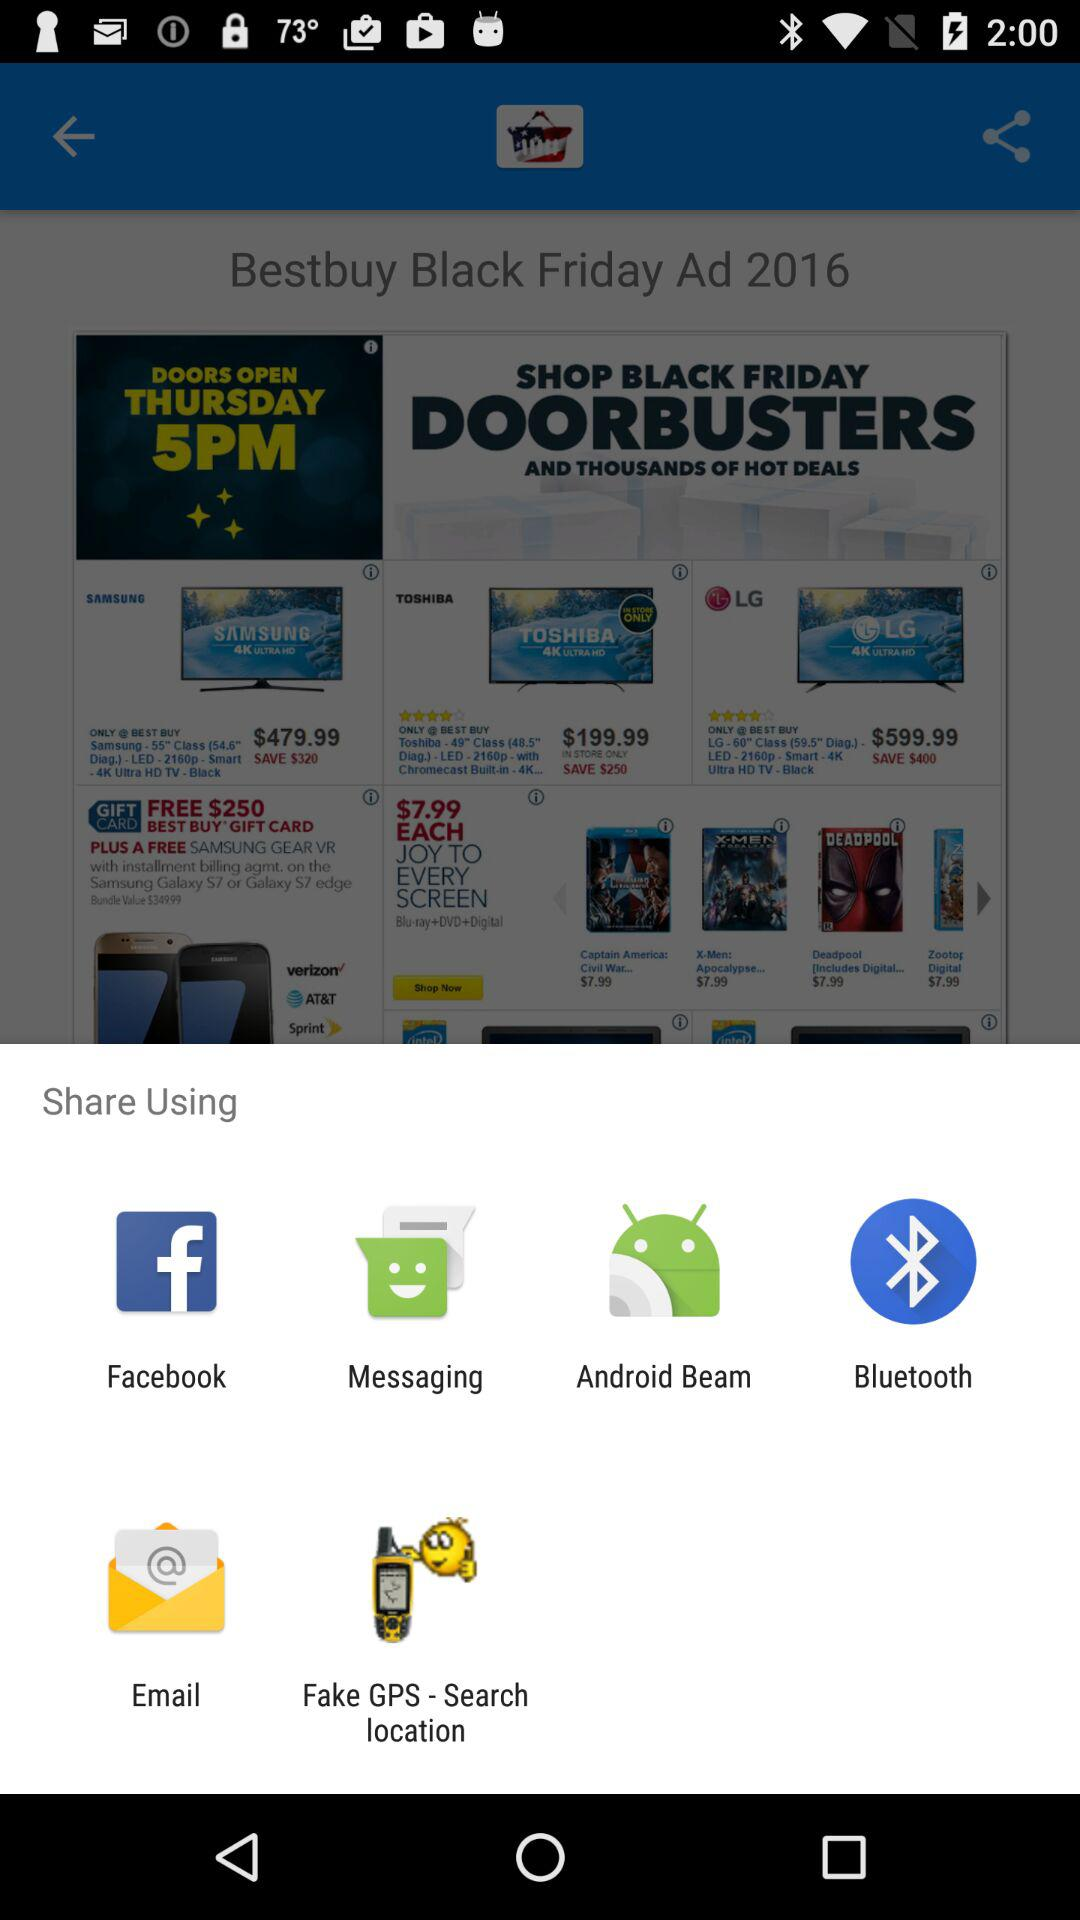Which applications can be used for sharing? The applications are "Facebook", "Messaging", "Android Beam", "Bluetooth", "Email" and "Fake GPS - Search location". 